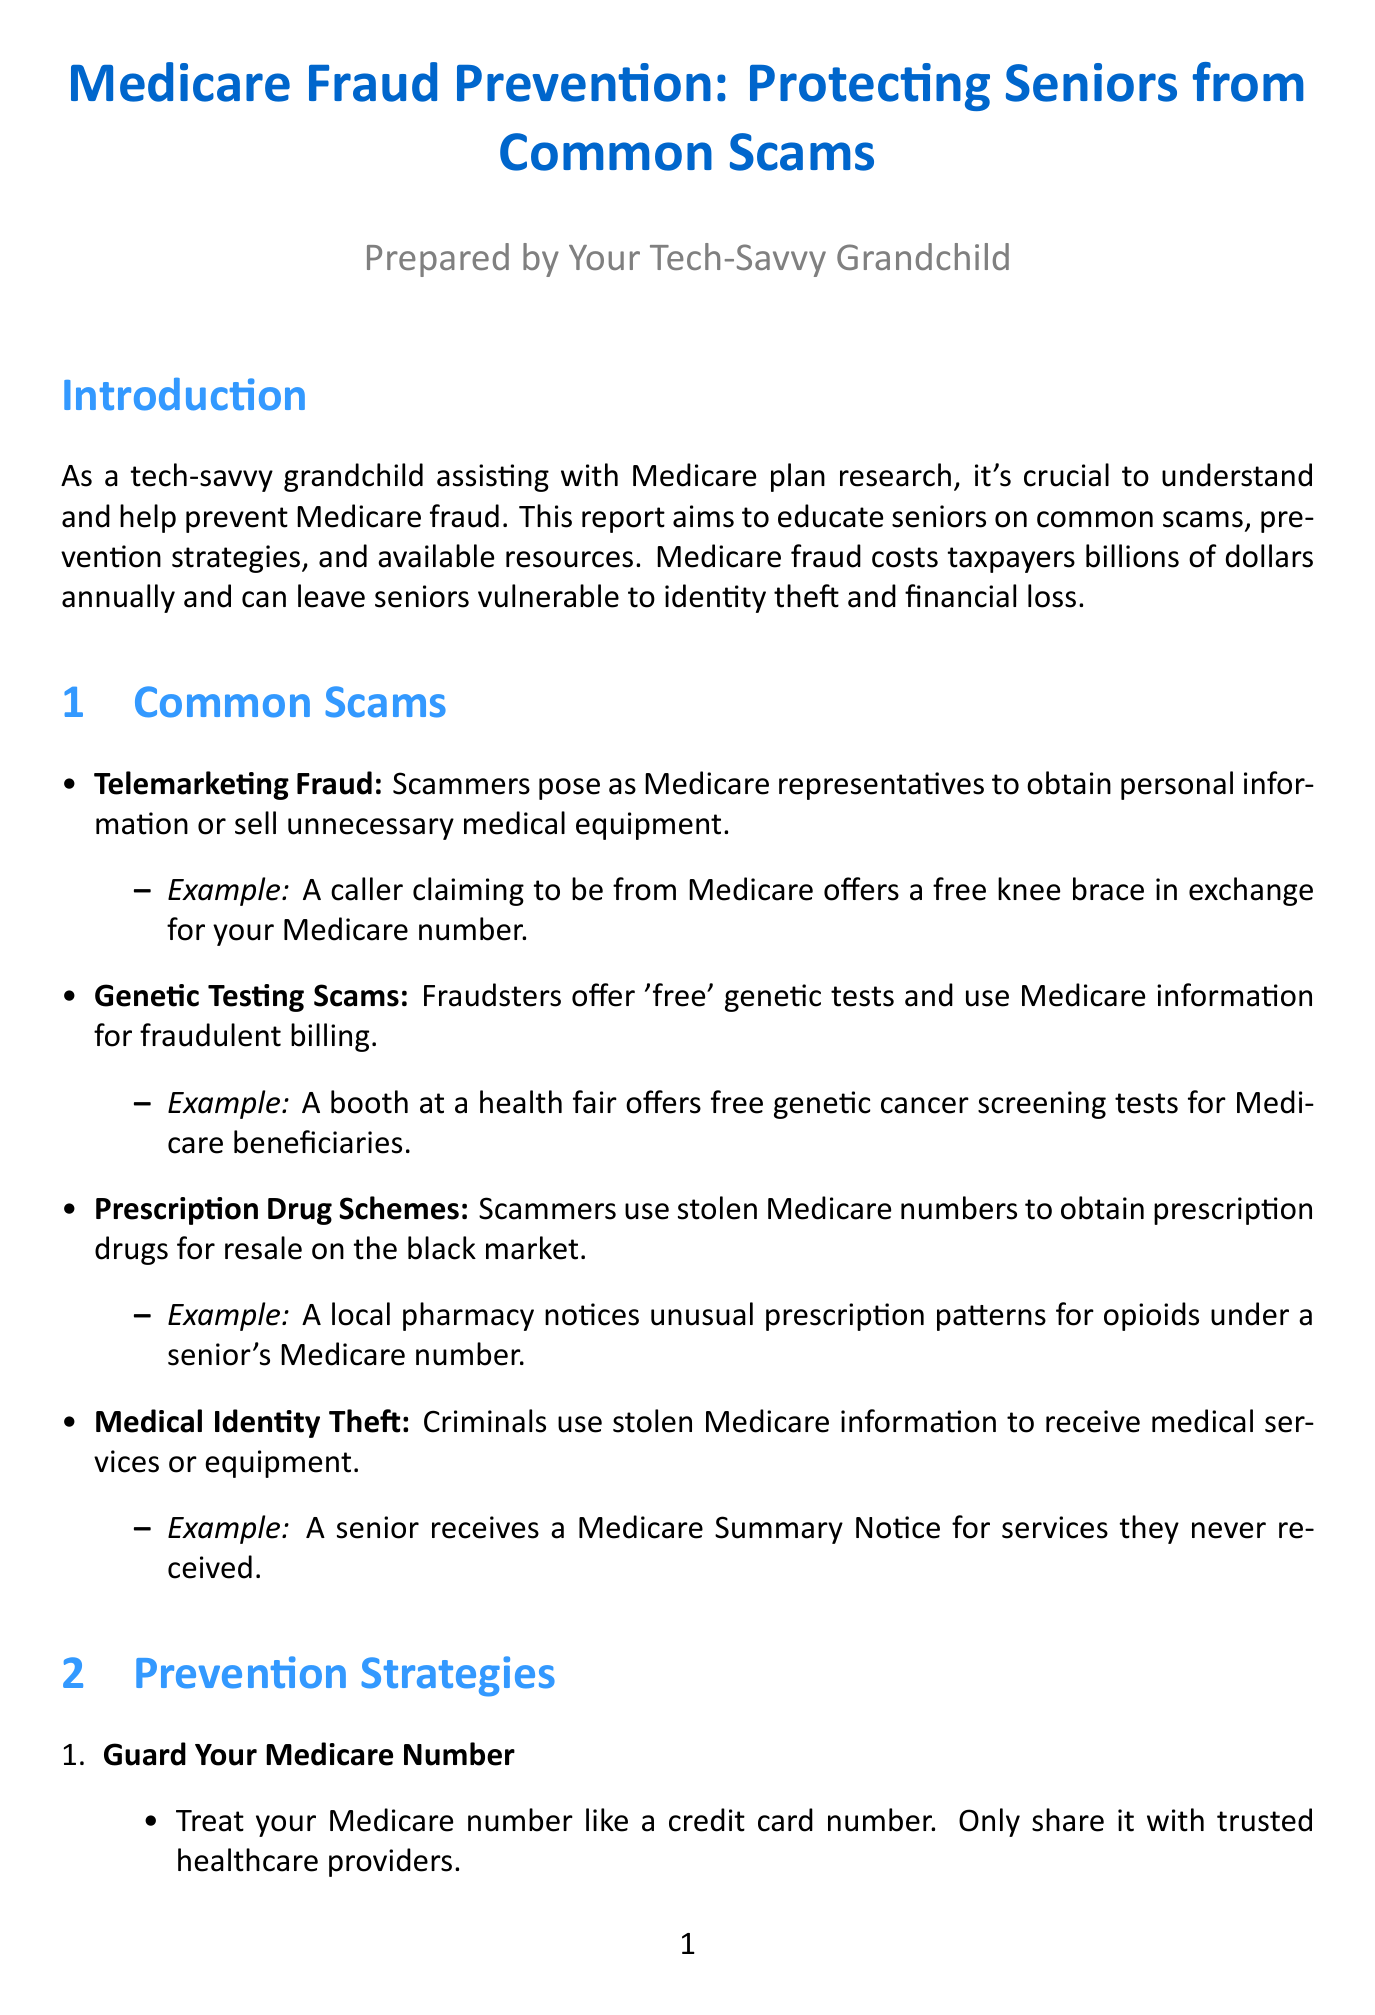What is the title of the report? The title of the report is stated at the beginning, highlighting its focus on fraud prevention for seniors.
Answer: Medicare Fraud Prevention: Protecting Seniors from Common Scams How many common scams are listed? The number of scams is indicated in the section discussing common scams, which lists four specific types.
Answer: Four What is one example of telemarketing fraud? The document provides an illustrative example under each common scam, specifically describing a scam involving a knee brace.
Answer: A caller claiming to be from Medicare offers a free knee brace in exchange for your Medicare number What is one recommended prevention strategy? The prevention strategies section suggests multiple strategies, one of which is about guarding personal information.
Answer: Guard Your Medicare Number What organization offers a national program for educating Medicare beneficiaries? The resources section names organizations, including one specifically focused on fraud prevention and education for seniors.
Answer: Senior Medicare Patrol (SMP) What contact number is provided for the Medicare Fraud Hotline? The report includes specific contact information for reporting fraud, such as hotlines for immediate assistance.
Answer: 1-800-HHS-TIPS (1-800-447-8477) What should seniors do before accepting medical equipment offers? The document emphasizes the importance of verifying offers, suggesting consulting a trusted professional.
Answer: Consult with your primary care physician What is the conclusion of the report about protecting seniors? The conclusion summarizes the overall message regarding vigilance and the role of family members in fraud prevention.
Answer: Staying vigilant and informed 